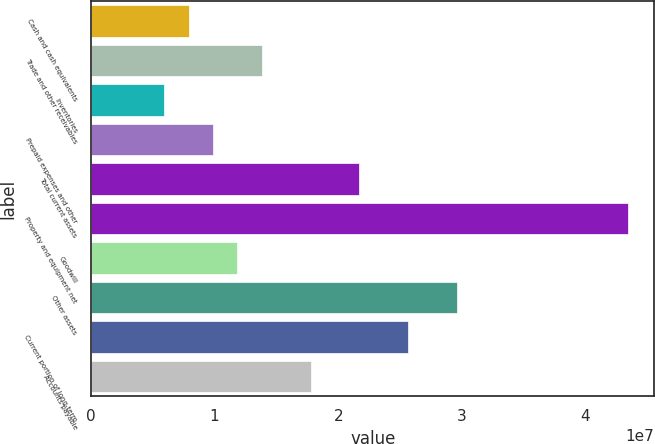Convert chart to OTSL. <chart><loc_0><loc_0><loc_500><loc_500><bar_chart><fcel>Cash and cash equivalents<fcel>Trade and other receivables<fcel>Inventories<fcel>Prepaid expenses and other<fcel>Total current assets<fcel>Property and equipment net<fcel>Goodwill<fcel>Other assets<fcel>Current portion of long-term<fcel>Accounts payable<nl><fcel>7.89548e+06<fcel>1.38153e+07<fcel>5.9222e+06<fcel>9.86877e+06<fcel>2.17085e+07<fcel>4.34146e+07<fcel>1.1842e+07<fcel>2.96016e+07<fcel>2.5655e+07<fcel>1.77619e+07<nl></chart> 